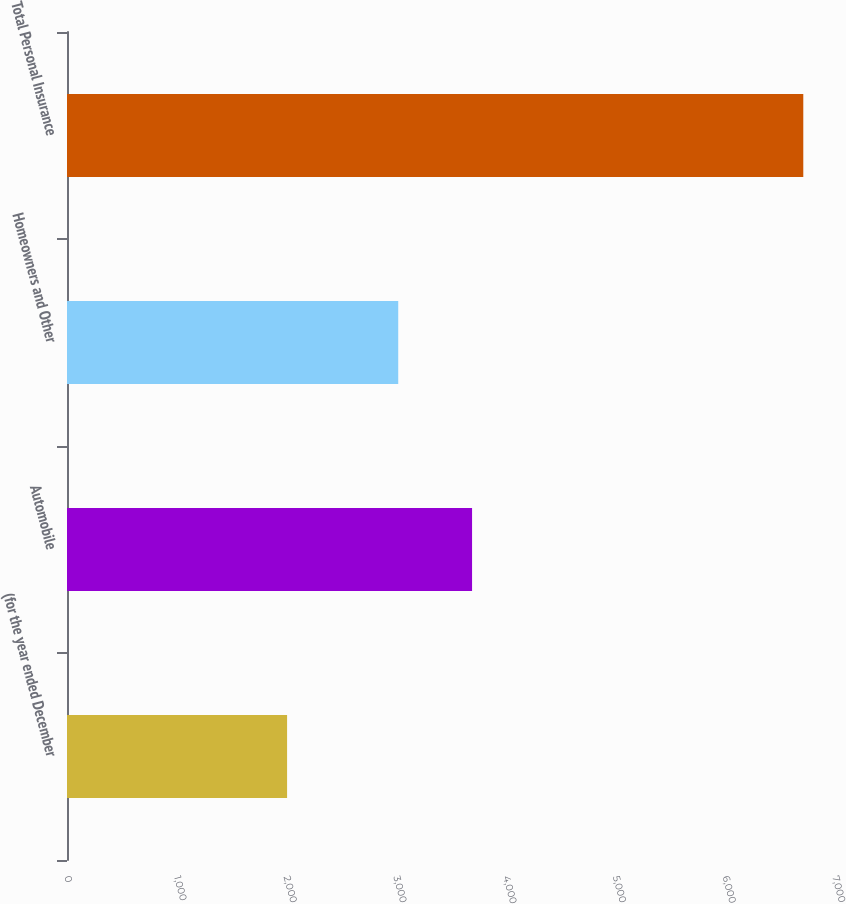<chart> <loc_0><loc_0><loc_500><loc_500><bar_chart><fcel>(for the year ended December<fcel>Automobile<fcel>Homeowners and Other<fcel>Total Personal Insurance<nl><fcel>2006<fcel>3692<fcel>3019<fcel>6711<nl></chart> 